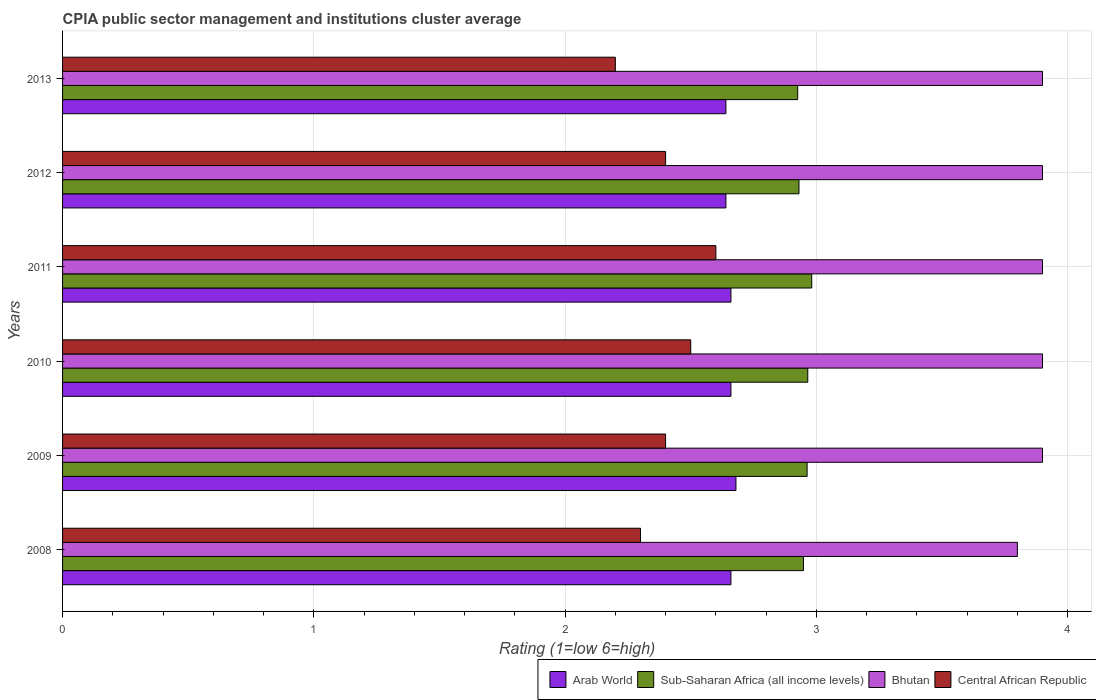How many bars are there on the 3rd tick from the bottom?
Your answer should be compact. 4. In how many cases, is the number of bars for a given year not equal to the number of legend labels?
Your response must be concise. 0. Across all years, what is the maximum CPIA rating in Arab World?
Your answer should be compact. 2.68. Across all years, what is the minimum CPIA rating in Sub-Saharan Africa (all income levels)?
Offer a very short reply. 2.93. In which year was the CPIA rating in Arab World maximum?
Offer a very short reply. 2009. What is the total CPIA rating in Bhutan in the graph?
Your response must be concise. 23.3. What is the difference between the CPIA rating in Arab World in 2009 and that in 2013?
Provide a short and direct response. 0.04. What is the difference between the CPIA rating in Sub-Saharan Africa (all income levels) in 2009 and the CPIA rating in Central African Republic in 2008?
Give a very brief answer. 0.66. In the year 2013, what is the difference between the CPIA rating in Arab World and CPIA rating in Central African Republic?
Make the answer very short. 0.44. What is the ratio of the CPIA rating in Sub-Saharan Africa (all income levels) in 2010 to that in 2011?
Make the answer very short. 0.99. Is the difference between the CPIA rating in Arab World in 2012 and 2013 greater than the difference between the CPIA rating in Central African Republic in 2012 and 2013?
Your answer should be very brief. No. What is the difference between the highest and the second highest CPIA rating in Arab World?
Your answer should be very brief. 0.02. What is the difference between the highest and the lowest CPIA rating in Central African Republic?
Offer a terse response. 0.4. Is the sum of the CPIA rating in Bhutan in 2011 and 2013 greater than the maximum CPIA rating in Arab World across all years?
Offer a terse response. Yes. What does the 2nd bar from the top in 2009 represents?
Make the answer very short. Bhutan. What does the 1st bar from the bottom in 2011 represents?
Offer a terse response. Arab World. Is it the case that in every year, the sum of the CPIA rating in Arab World and CPIA rating in Bhutan is greater than the CPIA rating in Sub-Saharan Africa (all income levels)?
Your answer should be compact. Yes. How many bars are there?
Your response must be concise. 24. Are all the bars in the graph horizontal?
Offer a very short reply. Yes. How many years are there in the graph?
Offer a terse response. 6. What is the difference between two consecutive major ticks on the X-axis?
Your response must be concise. 1. Does the graph contain grids?
Ensure brevity in your answer.  Yes. Where does the legend appear in the graph?
Your answer should be compact. Bottom right. How many legend labels are there?
Offer a terse response. 4. How are the legend labels stacked?
Offer a very short reply. Horizontal. What is the title of the graph?
Offer a terse response. CPIA public sector management and institutions cluster average. Does "Malta" appear as one of the legend labels in the graph?
Make the answer very short. No. What is the Rating (1=low 6=high) of Arab World in 2008?
Make the answer very short. 2.66. What is the Rating (1=low 6=high) of Sub-Saharan Africa (all income levels) in 2008?
Your answer should be very brief. 2.95. What is the Rating (1=low 6=high) in Bhutan in 2008?
Your response must be concise. 3.8. What is the Rating (1=low 6=high) of Arab World in 2009?
Offer a very short reply. 2.68. What is the Rating (1=low 6=high) of Sub-Saharan Africa (all income levels) in 2009?
Provide a short and direct response. 2.96. What is the Rating (1=low 6=high) in Bhutan in 2009?
Offer a terse response. 3.9. What is the Rating (1=low 6=high) in Arab World in 2010?
Offer a very short reply. 2.66. What is the Rating (1=low 6=high) in Sub-Saharan Africa (all income levels) in 2010?
Keep it short and to the point. 2.97. What is the Rating (1=low 6=high) of Arab World in 2011?
Your answer should be compact. 2.66. What is the Rating (1=low 6=high) of Sub-Saharan Africa (all income levels) in 2011?
Keep it short and to the point. 2.98. What is the Rating (1=low 6=high) in Bhutan in 2011?
Ensure brevity in your answer.  3.9. What is the Rating (1=low 6=high) of Central African Republic in 2011?
Make the answer very short. 2.6. What is the Rating (1=low 6=high) of Arab World in 2012?
Offer a very short reply. 2.64. What is the Rating (1=low 6=high) of Sub-Saharan Africa (all income levels) in 2012?
Keep it short and to the point. 2.93. What is the Rating (1=low 6=high) of Bhutan in 2012?
Ensure brevity in your answer.  3.9. What is the Rating (1=low 6=high) in Arab World in 2013?
Make the answer very short. 2.64. What is the Rating (1=low 6=high) in Sub-Saharan Africa (all income levels) in 2013?
Your response must be concise. 2.93. Across all years, what is the maximum Rating (1=low 6=high) in Arab World?
Make the answer very short. 2.68. Across all years, what is the maximum Rating (1=low 6=high) of Sub-Saharan Africa (all income levels)?
Provide a short and direct response. 2.98. Across all years, what is the maximum Rating (1=low 6=high) of Central African Republic?
Keep it short and to the point. 2.6. Across all years, what is the minimum Rating (1=low 6=high) in Arab World?
Provide a succinct answer. 2.64. Across all years, what is the minimum Rating (1=low 6=high) in Sub-Saharan Africa (all income levels)?
Offer a very short reply. 2.93. Across all years, what is the minimum Rating (1=low 6=high) in Central African Republic?
Offer a terse response. 2.2. What is the total Rating (1=low 6=high) of Arab World in the graph?
Provide a succinct answer. 15.94. What is the total Rating (1=low 6=high) of Sub-Saharan Africa (all income levels) in the graph?
Make the answer very short. 17.72. What is the total Rating (1=low 6=high) in Bhutan in the graph?
Your answer should be compact. 23.3. What is the total Rating (1=low 6=high) in Central African Republic in the graph?
Provide a succinct answer. 14.4. What is the difference between the Rating (1=low 6=high) in Arab World in 2008 and that in 2009?
Keep it short and to the point. -0.02. What is the difference between the Rating (1=low 6=high) in Sub-Saharan Africa (all income levels) in 2008 and that in 2009?
Offer a terse response. -0.01. What is the difference between the Rating (1=low 6=high) of Central African Republic in 2008 and that in 2009?
Provide a short and direct response. -0.1. What is the difference between the Rating (1=low 6=high) in Arab World in 2008 and that in 2010?
Keep it short and to the point. 0. What is the difference between the Rating (1=low 6=high) in Sub-Saharan Africa (all income levels) in 2008 and that in 2010?
Keep it short and to the point. -0.02. What is the difference between the Rating (1=low 6=high) of Bhutan in 2008 and that in 2010?
Your answer should be compact. -0.1. What is the difference between the Rating (1=low 6=high) of Sub-Saharan Africa (all income levels) in 2008 and that in 2011?
Offer a terse response. -0.03. What is the difference between the Rating (1=low 6=high) of Sub-Saharan Africa (all income levels) in 2008 and that in 2012?
Offer a terse response. 0.02. What is the difference between the Rating (1=low 6=high) of Bhutan in 2008 and that in 2012?
Offer a very short reply. -0.1. What is the difference between the Rating (1=low 6=high) of Central African Republic in 2008 and that in 2012?
Provide a succinct answer. -0.1. What is the difference between the Rating (1=low 6=high) in Arab World in 2008 and that in 2013?
Your response must be concise. 0.02. What is the difference between the Rating (1=low 6=high) of Sub-Saharan Africa (all income levels) in 2008 and that in 2013?
Your response must be concise. 0.02. What is the difference between the Rating (1=low 6=high) of Sub-Saharan Africa (all income levels) in 2009 and that in 2010?
Provide a short and direct response. -0. What is the difference between the Rating (1=low 6=high) of Sub-Saharan Africa (all income levels) in 2009 and that in 2011?
Your response must be concise. -0.02. What is the difference between the Rating (1=low 6=high) of Central African Republic in 2009 and that in 2011?
Keep it short and to the point. -0.2. What is the difference between the Rating (1=low 6=high) in Sub-Saharan Africa (all income levels) in 2009 and that in 2012?
Your response must be concise. 0.03. What is the difference between the Rating (1=low 6=high) in Central African Republic in 2009 and that in 2012?
Your response must be concise. 0. What is the difference between the Rating (1=low 6=high) in Arab World in 2009 and that in 2013?
Your response must be concise. 0.04. What is the difference between the Rating (1=low 6=high) in Sub-Saharan Africa (all income levels) in 2009 and that in 2013?
Give a very brief answer. 0.04. What is the difference between the Rating (1=low 6=high) of Bhutan in 2009 and that in 2013?
Keep it short and to the point. 0. What is the difference between the Rating (1=low 6=high) in Sub-Saharan Africa (all income levels) in 2010 and that in 2011?
Offer a terse response. -0.02. What is the difference between the Rating (1=low 6=high) of Central African Republic in 2010 and that in 2011?
Your response must be concise. -0.1. What is the difference between the Rating (1=low 6=high) of Sub-Saharan Africa (all income levels) in 2010 and that in 2012?
Offer a very short reply. 0.04. What is the difference between the Rating (1=low 6=high) of Arab World in 2010 and that in 2013?
Provide a short and direct response. 0.02. What is the difference between the Rating (1=low 6=high) of Sub-Saharan Africa (all income levels) in 2010 and that in 2013?
Your answer should be very brief. 0.04. What is the difference between the Rating (1=low 6=high) in Bhutan in 2010 and that in 2013?
Your response must be concise. 0. What is the difference between the Rating (1=low 6=high) in Sub-Saharan Africa (all income levels) in 2011 and that in 2012?
Ensure brevity in your answer.  0.05. What is the difference between the Rating (1=low 6=high) of Bhutan in 2011 and that in 2012?
Offer a very short reply. 0. What is the difference between the Rating (1=low 6=high) of Sub-Saharan Africa (all income levels) in 2011 and that in 2013?
Your answer should be compact. 0.06. What is the difference between the Rating (1=low 6=high) in Bhutan in 2011 and that in 2013?
Provide a succinct answer. 0. What is the difference between the Rating (1=low 6=high) in Central African Republic in 2011 and that in 2013?
Provide a succinct answer. 0.4. What is the difference between the Rating (1=low 6=high) in Arab World in 2012 and that in 2013?
Keep it short and to the point. 0. What is the difference between the Rating (1=low 6=high) of Sub-Saharan Africa (all income levels) in 2012 and that in 2013?
Provide a short and direct response. 0.01. What is the difference between the Rating (1=low 6=high) of Bhutan in 2012 and that in 2013?
Give a very brief answer. 0. What is the difference between the Rating (1=low 6=high) of Central African Republic in 2012 and that in 2013?
Offer a terse response. 0.2. What is the difference between the Rating (1=low 6=high) in Arab World in 2008 and the Rating (1=low 6=high) in Sub-Saharan Africa (all income levels) in 2009?
Offer a terse response. -0.3. What is the difference between the Rating (1=low 6=high) of Arab World in 2008 and the Rating (1=low 6=high) of Bhutan in 2009?
Provide a succinct answer. -1.24. What is the difference between the Rating (1=low 6=high) in Arab World in 2008 and the Rating (1=low 6=high) in Central African Republic in 2009?
Offer a terse response. 0.26. What is the difference between the Rating (1=low 6=high) in Sub-Saharan Africa (all income levels) in 2008 and the Rating (1=low 6=high) in Bhutan in 2009?
Keep it short and to the point. -0.95. What is the difference between the Rating (1=low 6=high) of Sub-Saharan Africa (all income levels) in 2008 and the Rating (1=low 6=high) of Central African Republic in 2009?
Your answer should be compact. 0.55. What is the difference between the Rating (1=low 6=high) of Arab World in 2008 and the Rating (1=low 6=high) of Sub-Saharan Africa (all income levels) in 2010?
Make the answer very short. -0.31. What is the difference between the Rating (1=low 6=high) of Arab World in 2008 and the Rating (1=low 6=high) of Bhutan in 2010?
Your answer should be compact. -1.24. What is the difference between the Rating (1=low 6=high) of Arab World in 2008 and the Rating (1=low 6=high) of Central African Republic in 2010?
Your answer should be very brief. 0.16. What is the difference between the Rating (1=low 6=high) in Sub-Saharan Africa (all income levels) in 2008 and the Rating (1=low 6=high) in Bhutan in 2010?
Your answer should be compact. -0.95. What is the difference between the Rating (1=low 6=high) in Sub-Saharan Africa (all income levels) in 2008 and the Rating (1=low 6=high) in Central African Republic in 2010?
Provide a short and direct response. 0.45. What is the difference between the Rating (1=low 6=high) in Arab World in 2008 and the Rating (1=low 6=high) in Sub-Saharan Africa (all income levels) in 2011?
Ensure brevity in your answer.  -0.32. What is the difference between the Rating (1=low 6=high) of Arab World in 2008 and the Rating (1=low 6=high) of Bhutan in 2011?
Offer a very short reply. -1.24. What is the difference between the Rating (1=low 6=high) of Arab World in 2008 and the Rating (1=low 6=high) of Central African Republic in 2011?
Make the answer very short. 0.06. What is the difference between the Rating (1=low 6=high) in Sub-Saharan Africa (all income levels) in 2008 and the Rating (1=low 6=high) in Bhutan in 2011?
Give a very brief answer. -0.95. What is the difference between the Rating (1=low 6=high) in Sub-Saharan Africa (all income levels) in 2008 and the Rating (1=low 6=high) in Central African Republic in 2011?
Your answer should be compact. 0.35. What is the difference between the Rating (1=low 6=high) of Arab World in 2008 and the Rating (1=low 6=high) of Sub-Saharan Africa (all income levels) in 2012?
Offer a terse response. -0.27. What is the difference between the Rating (1=low 6=high) in Arab World in 2008 and the Rating (1=low 6=high) in Bhutan in 2012?
Ensure brevity in your answer.  -1.24. What is the difference between the Rating (1=low 6=high) in Arab World in 2008 and the Rating (1=low 6=high) in Central African Republic in 2012?
Your answer should be compact. 0.26. What is the difference between the Rating (1=low 6=high) in Sub-Saharan Africa (all income levels) in 2008 and the Rating (1=low 6=high) in Bhutan in 2012?
Make the answer very short. -0.95. What is the difference between the Rating (1=low 6=high) of Sub-Saharan Africa (all income levels) in 2008 and the Rating (1=low 6=high) of Central African Republic in 2012?
Your answer should be compact. 0.55. What is the difference between the Rating (1=low 6=high) in Arab World in 2008 and the Rating (1=low 6=high) in Sub-Saharan Africa (all income levels) in 2013?
Offer a terse response. -0.27. What is the difference between the Rating (1=low 6=high) in Arab World in 2008 and the Rating (1=low 6=high) in Bhutan in 2013?
Offer a very short reply. -1.24. What is the difference between the Rating (1=low 6=high) in Arab World in 2008 and the Rating (1=low 6=high) in Central African Republic in 2013?
Your response must be concise. 0.46. What is the difference between the Rating (1=low 6=high) of Sub-Saharan Africa (all income levels) in 2008 and the Rating (1=low 6=high) of Bhutan in 2013?
Provide a succinct answer. -0.95. What is the difference between the Rating (1=low 6=high) of Sub-Saharan Africa (all income levels) in 2008 and the Rating (1=low 6=high) of Central African Republic in 2013?
Your response must be concise. 0.75. What is the difference between the Rating (1=low 6=high) in Bhutan in 2008 and the Rating (1=low 6=high) in Central African Republic in 2013?
Offer a terse response. 1.6. What is the difference between the Rating (1=low 6=high) in Arab World in 2009 and the Rating (1=low 6=high) in Sub-Saharan Africa (all income levels) in 2010?
Provide a short and direct response. -0.29. What is the difference between the Rating (1=low 6=high) in Arab World in 2009 and the Rating (1=low 6=high) in Bhutan in 2010?
Your answer should be very brief. -1.22. What is the difference between the Rating (1=low 6=high) of Arab World in 2009 and the Rating (1=low 6=high) of Central African Republic in 2010?
Your answer should be compact. 0.18. What is the difference between the Rating (1=low 6=high) of Sub-Saharan Africa (all income levels) in 2009 and the Rating (1=low 6=high) of Bhutan in 2010?
Offer a terse response. -0.94. What is the difference between the Rating (1=low 6=high) in Sub-Saharan Africa (all income levels) in 2009 and the Rating (1=low 6=high) in Central African Republic in 2010?
Keep it short and to the point. 0.46. What is the difference between the Rating (1=low 6=high) in Bhutan in 2009 and the Rating (1=low 6=high) in Central African Republic in 2010?
Offer a very short reply. 1.4. What is the difference between the Rating (1=low 6=high) of Arab World in 2009 and the Rating (1=low 6=high) of Sub-Saharan Africa (all income levels) in 2011?
Offer a very short reply. -0.3. What is the difference between the Rating (1=low 6=high) in Arab World in 2009 and the Rating (1=low 6=high) in Bhutan in 2011?
Ensure brevity in your answer.  -1.22. What is the difference between the Rating (1=low 6=high) of Sub-Saharan Africa (all income levels) in 2009 and the Rating (1=low 6=high) of Bhutan in 2011?
Your answer should be very brief. -0.94. What is the difference between the Rating (1=low 6=high) of Sub-Saharan Africa (all income levels) in 2009 and the Rating (1=low 6=high) of Central African Republic in 2011?
Your answer should be compact. 0.36. What is the difference between the Rating (1=low 6=high) of Arab World in 2009 and the Rating (1=low 6=high) of Sub-Saharan Africa (all income levels) in 2012?
Offer a very short reply. -0.25. What is the difference between the Rating (1=low 6=high) of Arab World in 2009 and the Rating (1=low 6=high) of Bhutan in 2012?
Offer a very short reply. -1.22. What is the difference between the Rating (1=low 6=high) of Arab World in 2009 and the Rating (1=low 6=high) of Central African Republic in 2012?
Your response must be concise. 0.28. What is the difference between the Rating (1=low 6=high) in Sub-Saharan Africa (all income levels) in 2009 and the Rating (1=low 6=high) in Bhutan in 2012?
Keep it short and to the point. -0.94. What is the difference between the Rating (1=low 6=high) in Sub-Saharan Africa (all income levels) in 2009 and the Rating (1=low 6=high) in Central African Republic in 2012?
Keep it short and to the point. 0.56. What is the difference between the Rating (1=low 6=high) in Arab World in 2009 and the Rating (1=low 6=high) in Sub-Saharan Africa (all income levels) in 2013?
Provide a succinct answer. -0.25. What is the difference between the Rating (1=low 6=high) in Arab World in 2009 and the Rating (1=low 6=high) in Bhutan in 2013?
Offer a terse response. -1.22. What is the difference between the Rating (1=low 6=high) in Arab World in 2009 and the Rating (1=low 6=high) in Central African Republic in 2013?
Provide a succinct answer. 0.48. What is the difference between the Rating (1=low 6=high) in Sub-Saharan Africa (all income levels) in 2009 and the Rating (1=low 6=high) in Bhutan in 2013?
Offer a terse response. -0.94. What is the difference between the Rating (1=low 6=high) of Sub-Saharan Africa (all income levels) in 2009 and the Rating (1=low 6=high) of Central African Republic in 2013?
Offer a very short reply. 0.76. What is the difference between the Rating (1=low 6=high) in Arab World in 2010 and the Rating (1=low 6=high) in Sub-Saharan Africa (all income levels) in 2011?
Offer a terse response. -0.32. What is the difference between the Rating (1=low 6=high) of Arab World in 2010 and the Rating (1=low 6=high) of Bhutan in 2011?
Make the answer very short. -1.24. What is the difference between the Rating (1=low 6=high) in Arab World in 2010 and the Rating (1=low 6=high) in Central African Republic in 2011?
Keep it short and to the point. 0.06. What is the difference between the Rating (1=low 6=high) of Sub-Saharan Africa (all income levels) in 2010 and the Rating (1=low 6=high) of Bhutan in 2011?
Make the answer very short. -0.93. What is the difference between the Rating (1=low 6=high) in Sub-Saharan Africa (all income levels) in 2010 and the Rating (1=low 6=high) in Central African Republic in 2011?
Make the answer very short. 0.37. What is the difference between the Rating (1=low 6=high) of Bhutan in 2010 and the Rating (1=low 6=high) of Central African Republic in 2011?
Keep it short and to the point. 1.3. What is the difference between the Rating (1=low 6=high) in Arab World in 2010 and the Rating (1=low 6=high) in Sub-Saharan Africa (all income levels) in 2012?
Your response must be concise. -0.27. What is the difference between the Rating (1=low 6=high) in Arab World in 2010 and the Rating (1=low 6=high) in Bhutan in 2012?
Provide a succinct answer. -1.24. What is the difference between the Rating (1=low 6=high) in Arab World in 2010 and the Rating (1=low 6=high) in Central African Republic in 2012?
Provide a short and direct response. 0.26. What is the difference between the Rating (1=low 6=high) of Sub-Saharan Africa (all income levels) in 2010 and the Rating (1=low 6=high) of Bhutan in 2012?
Give a very brief answer. -0.93. What is the difference between the Rating (1=low 6=high) of Sub-Saharan Africa (all income levels) in 2010 and the Rating (1=low 6=high) of Central African Republic in 2012?
Your answer should be very brief. 0.57. What is the difference between the Rating (1=low 6=high) of Bhutan in 2010 and the Rating (1=low 6=high) of Central African Republic in 2012?
Give a very brief answer. 1.5. What is the difference between the Rating (1=low 6=high) of Arab World in 2010 and the Rating (1=low 6=high) of Sub-Saharan Africa (all income levels) in 2013?
Make the answer very short. -0.27. What is the difference between the Rating (1=low 6=high) of Arab World in 2010 and the Rating (1=low 6=high) of Bhutan in 2013?
Make the answer very short. -1.24. What is the difference between the Rating (1=low 6=high) of Arab World in 2010 and the Rating (1=low 6=high) of Central African Republic in 2013?
Ensure brevity in your answer.  0.46. What is the difference between the Rating (1=low 6=high) of Sub-Saharan Africa (all income levels) in 2010 and the Rating (1=low 6=high) of Bhutan in 2013?
Your answer should be compact. -0.93. What is the difference between the Rating (1=low 6=high) of Sub-Saharan Africa (all income levels) in 2010 and the Rating (1=low 6=high) of Central African Republic in 2013?
Your answer should be compact. 0.77. What is the difference between the Rating (1=low 6=high) in Bhutan in 2010 and the Rating (1=low 6=high) in Central African Republic in 2013?
Your response must be concise. 1.7. What is the difference between the Rating (1=low 6=high) of Arab World in 2011 and the Rating (1=low 6=high) of Sub-Saharan Africa (all income levels) in 2012?
Give a very brief answer. -0.27. What is the difference between the Rating (1=low 6=high) in Arab World in 2011 and the Rating (1=low 6=high) in Bhutan in 2012?
Ensure brevity in your answer.  -1.24. What is the difference between the Rating (1=low 6=high) of Arab World in 2011 and the Rating (1=low 6=high) of Central African Republic in 2012?
Keep it short and to the point. 0.26. What is the difference between the Rating (1=low 6=high) of Sub-Saharan Africa (all income levels) in 2011 and the Rating (1=low 6=high) of Bhutan in 2012?
Your answer should be very brief. -0.92. What is the difference between the Rating (1=low 6=high) of Sub-Saharan Africa (all income levels) in 2011 and the Rating (1=low 6=high) of Central African Republic in 2012?
Your response must be concise. 0.58. What is the difference between the Rating (1=low 6=high) in Arab World in 2011 and the Rating (1=low 6=high) in Sub-Saharan Africa (all income levels) in 2013?
Ensure brevity in your answer.  -0.27. What is the difference between the Rating (1=low 6=high) in Arab World in 2011 and the Rating (1=low 6=high) in Bhutan in 2013?
Provide a succinct answer. -1.24. What is the difference between the Rating (1=low 6=high) in Arab World in 2011 and the Rating (1=low 6=high) in Central African Republic in 2013?
Your response must be concise. 0.46. What is the difference between the Rating (1=low 6=high) of Sub-Saharan Africa (all income levels) in 2011 and the Rating (1=low 6=high) of Bhutan in 2013?
Provide a succinct answer. -0.92. What is the difference between the Rating (1=low 6=high) of Sub-Saharan Africa (all income levels) in 2011 and the Rating (1=low 6=high) of Central African Republic in 2013?
Keep it short and to the point. 0.78. What is the difference between the Rating (1=low 6=high) in Arab World in 2012 and the Rating (1=low 6=high) in Sub-Saharan Africa (all income levels) in 2013?
Your response must be concise. -0.29. What is the difference between the Rating (1=low 6=high) of Arab World in 2012 and the Rating (1=low 6=high) of Bhutan in 2013?
Offer a terse response. -1.26. What is the difference between the Rating (1=low 6=high) in Arab World in 2012 and the Rating (1=low 6=high) in Central African Republic in 2013?
Ensure brevity in your answer.  0.44. What is the difference between the Rating (1=low 6=high) in Sub-Saharan Africa (all income levels) in 2012 and the Rating (1=low 6=high) in Bhutan in 2013?
Your answer should be compact. -0.97. What is the difference between the Rating (1=low 6=high) in Sub-Saharan Africa (all income levels) in 2012 and the Rating (1=low 6=high) in Central African Republic in 2013?
Keep it short and to the point. 0.73. What is the average Rating (1=low 6=high) of Arab World per year?
Your answer should be compact. 2.66. What is the average Rating (1=low 6=high) in Sub-Saharan Africa (all income levels) per year?
Your answer should be very brief. 2.95. What is the average Rating (1=low 6=high) in Bhutan per year?
Provide a succinct answer. 3.88. In the year 2008, what is the difference between the Rating (1=low 6=high) of Arab World and Rating (1=low 6=high) of Sub-Saharan Africa (all income levels)?
Ensure brevity in your answer.  -0.29. In the year 2008, what is the difference between the Rating (1=low 6=high) in Arab World and Rating (1=low 6=high) in Bhutan?
Your answer should be compact. -1.14. In the year 2008, what is the difference between the Rating (1=low 6=high) in Arab World and Rating (1=low 6=high) in Central African Republic?
Your response must be concise. 0.36. In the year 2008, what is the difference between the Rating (1=low 6=high) of Sub-Saharan Africa (all income levels) and Rating (1=low 6=high) of Bhutan?
Give a very brief answer. -0.85. In the year 2008, what is the difference between the Rating (1=low 6=high) in Sub-Saharan Africa (all income levels) and Rating (1=low 6=high) in Central African Republic?
Offer a terse response. 0.65. In the year 2008, what is the difference between the Rating (1=low 6=high) in Bhutan and Rating (1=low 6=high) in Central African Republic?
Your answer should be very brief. 1.5. In the year 2009, what is the difference between the Rating (1=low 6=high) in Arab World and Rating (1=low 6=high) in Sub-Saharan Africa (all income levels)?
Keep it short and to the point. -0.28. In the year 2009, what is the difference between the Rating (1=low 6=high) of Arab World and Rating (1=low 6=high) of Bhutan?
Your response must be concise. -1.22. In the year 2009, what is the difference between the Rating (1=low 6=high) in Arab World and Rating (1=low 6=high) in Central African Republic?
Your answer should be compact. 0.28. In the year 2009, what is the difference between the Rating (1=low 6=high) of Sub-Saharan Africa (all income levels) and Rating (1=low 6=high) of Bhutan?
Give a very brief answer. -0.94. In the year 2009, what is the difference between the Rating (1=low 6=high) in Sub-Saharan Africa (all income levels) and Rating (1=low 6=high) in Central African Republic?
Your answer should be compact. 0.56. In the year 2009, what is the difference between the Rating (1=low 6=high) of Bhutan and Rating (1=low 6=high) of Central African Republic?
Provide a short and direct response. 1.5. In the year 2010, what is the difference between the Rating (1=low 6=high) of Arab World and Rating (1=low 6=high) of Sub-Saharan Africa (all income levels)?
Provide a short and direct response. -0.31. In the year 2010, what is the difference between the Rating (1=low 6=high) in Arab World and Rating (1=low 6=high) in Bhutan?
Give a very brief answer. -1.24. In the year 2010, what is the difference between the Rating (1=low 6=high) in Arab World and Rating (1=low 6=high) in Central African Republic?
Provide a succinct answer. 0.16. In the year 2010, what is the difference between the Rating (1=low 6=high) in Sub-Saharan Africa (all income levels) and Rating (1=low 6=high) in Bhutan?
Provide a succinct answer. -0.93. In the year 2010, what is the difference between the Rating (1=low 6=high) in Sub-Saharan Africa (all income levels) and Rating (1=low 6=high) in Central African Republic?
Keep it short and to the point. 0.47. In the year 2010, what is the difference between the Rating (1=low 6=high) of Bhutan and Rating (1=low 6=high) of Central African Republic?
Ensure brevity in your answer.  1.4. In the year 2011, what is the difference between the Rating (1=low 6=high) in Arab World and Rating (1=low 6=high) in Sub-Saharan Africa (all income levels)?
Your response must be concise. -0.32. In the year 2011, what is the difference between the Rating (1=low 6=high) of Arab World and Rating (1=low 6=high) of Bhutan?
Provide a succinct answer. -1.24. In the year 2011, what is the difference between the Rating (1=low 6=high) of Arab World and Rating (1=low 6=high) of Central African Republic?
Your answer should be very brief. 0.06. In the year 2011, what is the difference between the Rating (1=low 6=high) of Sub-Saharan Africa (all income levels) and Rating (1=low 6=high) of Bhutan?
Your answer should be compact. -0.92. In the year 2011, what is the difference between the Rating (1=low 6=high) of Sub-Saharan Africa (all income levels) and Rating (1=low 6=high) of Central African Republic?
Make the answer very short. 0.38. In the year 2011, what is the difference between the Rating (1=low 6=high) in Bhutan and Rating (1=low 6=high) in Central African Republic?
Your answer should be compact. 1.3. In the year 2012, what is the difference between the Rating (1=low 6=high) of Arab World and Rating (1=low 6=high) of Sub-Saharan Africa (all income levels)?
Offer a very short reply. -0.29. In the year 2012, what is the difference between the Rating (1=low 6=high) of Arab World and Rating (1=low 6=high) of Bhutan?
Provide a succinct answer. -1.26. In the year 2012, what is the difference between the Rating (1=low 6=high) of Arab World and Rating (1=low 6=high) of Central African Republic?
Offer a very short reply. 0.24. In the year 2012, what is the difference between the Rating (1=low 6=high) of Sub-Saharan Africa (all income levels) and Rating (1=low 6=high) of Bhutan?
Your response must be concise. -0.97. In the year 2012, what is the difference between the Rating (1=low 6=high) of Sub-Saharan Africa (all income levels) and Rating (1=low 6=high) of Central African Republic?
Give a very brief answer. 0.53. In the year 2012, what is the difference between the Rating (1=low 6=high) in Bhutan and Rating (1=low 6=high) in Central African Republic?
Make the answer very short. 1.5. In the year 2013, what is the difference between the Rating (1=low 6=high) in Arab World and Rating (1=low 6=high) in Sub-Saharan Africa (all income levels)?
Give a very brief answer. -0.29. In the year 2013, what is the difference between the Rating (1=low 6=high) in Arab World and Rating (1=low 6=high) in Bhutan?
Provide a short and direct response. -1.26. In the year 2013, what is the difference between the Rating (1=low 6=high) of Arab World and Rating (1=low 6=high) of Central African Republic?
Ensure brevity in your answer.  0.44. In the year 2013, what is the difference between the Rating (1=low 6=high) in Sub-Saharan Africa (all income levels) and Rating (1=low 6=high) in Bhutan?
Your answer should be very brief. -0.97. In the year 2013, what is the difference between the Rating (1=low 6=high) of Sub-Saharan Africa (all income levels) and Rating (1=low 6=high) of Central African Republic?
Ensure brevity in your answer.  0.73. What is the ratio of the Rating (1=low 6=high) in Arab World in 2008 to that in 2009?
Offer a terse response. 0.99. What is the ratio of the Rating (1=low 6=high) in Sub-Saharan Africa (all income levels) in 2008 to that in 2009?
Keep it short and to the point. 1. What is the ratio of the Rating (1=low 6=high) in Bhutan in 2008 to that in 2009?
Your answer should be compact. 0.97. What is the ratio of the Rating (1=low 6=high) of Central African Republic in 2008 to that in 2009?
Offer a terse response. 0.96. What is the ratio of the Rating (1=low 6=high) in Arab World in 2008 to that in 2010?
Give a very brief answer. 1. What is the ratio of the Rating (1=low 6=high) in Sub-Saharan Africa (all income levels) in 2008 to that in 2010?
Provide a succinct answer. 0.99. What is the ratio of the Rating (1=low 6=high) in Bhutan in 2008 to that in 2010?
Provide a short and direct response. 0.97. What is the ratio of the Rating (1=low 6=high) in Bhutan in 2008 to that in 2011?
Offer a terse response. 0.97. What is the ratio of the Rating (1=low 6=high) in Central African Republic in 2008 to that in 2011?
Give a very brief answer. 0.88. What is the ratio of the Rating (1=low 6=high) of Arab World in 2008 to that in 2012?
Provide a succinct answer. 1.01. What is the ratio of the Rating (1=low 6=high) of Sub-Saharan Africa (all income levels) in 2008 to that in 2012?
Your answer should be compact. 1.01. What is the ratio of the Rating (1=low 6=high) of Bhutan in 2008 to that in 2012?
Your answer should be compact. 0.97. What is the ratio of the Rating (1=low 6=high) in Central African Republic in 2008 to that in 2012?
Make the answer very short. 0.96. What is the ratio of the Rating (1=low 6=high) in Arab World in 2008 to that in 2013?
Your answer should be compact. 1.01. What is the ratio of the Rating (1=low 6=high) in Sub-Saharan Africa (all income levels) in 2008 to that in 2013?
Keep it short and to the point. 1.01. What is the ratio of the Rating (1=low 6=high) in Bhutan in 2008 to that in 2013?
Offer a very short reply. 0.97. What is the ratio of the Rating (1=low 6=high) of Central African Republic in 2008 to that in 2013?
Provide a succinct answer. 1.05. What is the ratio of the Rating (1=low 6=high) of Arab World in 2009 to that in 2010?
Provide a short and direct response. 1.01. What is the ratio of the Rating (1=low 6=high) in Central African Republic in 2009 to that in 2010?
Your answer should be compact. 0.96. What is the ratio of the Rating (1=low 6=high) of Arab World in 2009 to that in 2011?
Keep it short and to the point. 1.01. What is the ratio of the Rating (1=low 6=high) of Sub-Saharan Africa (all income levels) in 2009 to that in 2011?
Give a very brief answer. 0.99. What is the ratio of the Rating (1=low 6=high) of Arab World in 2009 to that in 2012?
Your answer should be compact. 1.02. What is the ratio of the Rating (1=low 6=high) of Sub-Saharan Africa (all income levels) in 2009 to that in 2012?
Your answer should be compact. 1.01. What is the ratio of the Rating (1=low 6=high) of Bhutan in 2009 to that in 2012?
Your answer should be compact. 1. What is the ratio of the Rating (1=low 6=high) of Central African Republic in 2009 to that in 2012?
Make the answer very short. 1. What is the ratio of the Rating (1=low 6=high) of Arab World in 2009 to that in 2013?
Make the answer very short. 1.02. What is the ratio of the Rating (1=low 6=high) of Sub-Saharan Africa (all income levels) in 2009 to that in 2013?
Give a very brief answer. 1.01. What is the ratio of the Rating (1=low 6=high) in Bhutan in 2009 to that in 2013?
Give a very brief answer. 1. What is the ratio of the Rating (1=low 6=high) in Arab World in 2010 to that in 2011?
Provide a succinct answer. 1. What is the ratio of the Rating (1=low 6=high) of Sub-Saharan Africa (all income levels) in 2010 to that in 2011?
Your answer should be compact. 0.99. What is the ratio of the Rating (1=low 6=high) in Bhutan in 2010 to that in 2011?
Provide a short and direct response. 1. What is the ratio of the Rating (1=low 6=high) in Central African Republic in 2010 to that in 2011?
Make the answer very short. 0.96. What is the ratio of the Rating (1=low 6=high) of Arab World in 2010 to that in 2012?
Ensure brevity in your answer.  1.01. What is the ratio of the Rating (1=low 6=high) of Sub-Saharan Africa (all income levels) in 2010 to that in 2012?
Your answer should be very brief. 1.01. What is the ratio of the Rating (1=low 6=high) in Bhutan in 2010 to that in 2012?
Give a very brief answer. 1. What is the ratio of the Rating (1=low 6=high) in Central African Republic in 2010 to that in 2012?
Keep it short and to the point. 1.04. What is the ratio of the Rating (1=low 6=high) of Arab World in 2010 to that in 2013?
Offer a terse response. 1.01. What is the ratio of the Rating (1=low 6=high) in Sub-Saharan Africa (all income levels) in 2010 to that in 2013?
Offer a very short reply. 1.01. What is the ratio of the Rating (1=low 6=high) in Bhutan in 2010 to that in 2013?
Provide a short and direct response. 1. What is the ratio of the Rating (1=low 6=high) of Central African Republic in 2010 to that in 2013?
Ensure brevity in your answer.  1.14. What is the ratio of the Rating (1=low 6=high) in Arab World in 2011 to that in 2012?
Offer a terse response. 1.01. What is the ratio of the Rating (1=low 6=high) in Sub-Saharan Africa (all income levels) in 2011 to that in 2012?
Give a very brief answer. 1.02. What is the ratio of the Rating (1=low 6=high) in Central African Republic in 2011 to that in 2012?
Your answer should be very brief. 1.08. What is the ratio of the Rating (1=low 6=high) of Arab World in 2011 to that in 2013?
Provide a succinct answer. 1.01. What is the ratio of the Rating (1=low 6=high) in Sub-Saharan Africa (all income levels) in 2011 to that in 2013?
Make the answer very short. 1.02. What is the ratio of the Rating (1=low 6=high) of Central African Republic in 2011 to that in 2013?
Offer a very short reply. 1.18. What is the ratio of the Rating (1=low 6=high) of Arab World in 2012 to that in 2013?
Keep it short and to the point. 1. What is the ratio of the Rating (1=low 6=high) of Bhutan in 2012 to that in 2013?
Make the answer very short. 1. What is the ratio of the Rating (1=low 6=high) in Central African Republic in 2012 to that in 2013?
Your response must be concise. 1.09. What is the difference between the highest and the second highest Rating (1=low 6=high) of Arab World?
Your response must be concise. 0.02. What is the difference between the highest and the second highest Rating (1=low 6=high) in Sub-Saharan Africa (all income levels)?
Ensure brevity in your answer.  0.02. What is the difference between the highest and the second highest Rating (1=low 6=high) in Central African Republic?
Give a very brief answer. 0.1. What is the difference between the highest and the lowest Rating (1=low 6=high) in Sub-Saharan Africa (all income levels)?
Your answer should be very brief. 0.06. What is the difference between the highest and the lowest Rating (1=low 6=high) of Bhutan?
Ensure brevity in your answer.  0.1. 